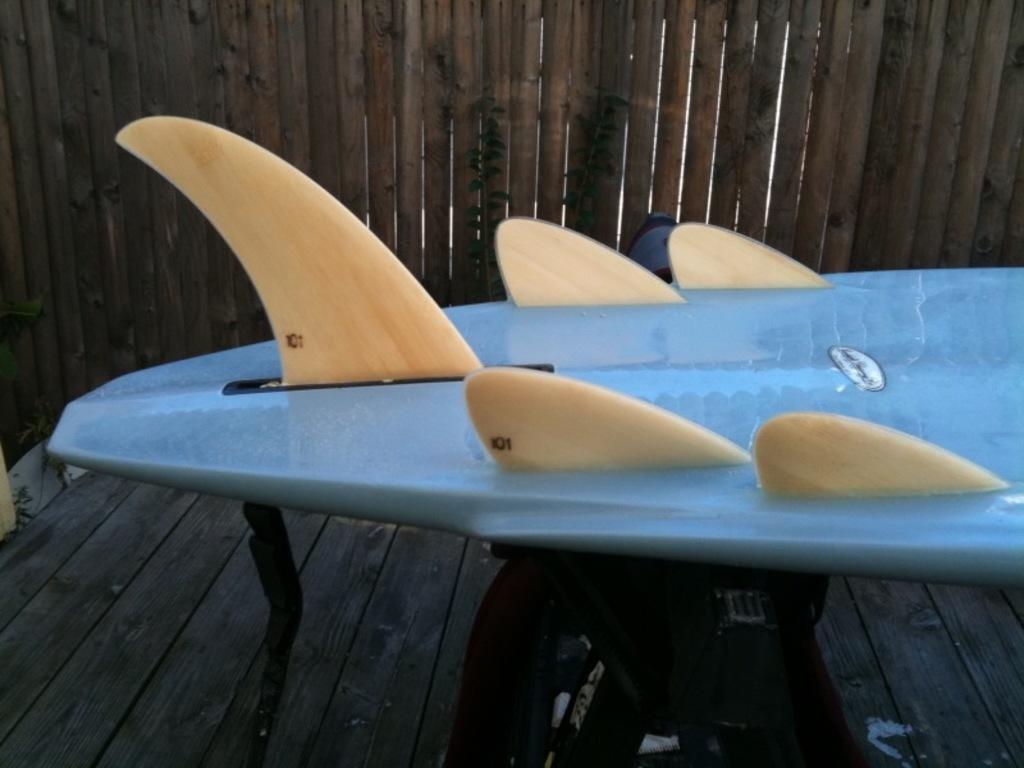What object is the main focus of the image? There is a surfing board in the image. Where is the surfing board located? The surfing board is placed on a table. What type of material can be seen in the background of the image? There is wood visible in the background of the image. What type of spark can be seen coming from the surfing board in the image? There is no spark visible in the image; the surfing board is simply placed on a table. 